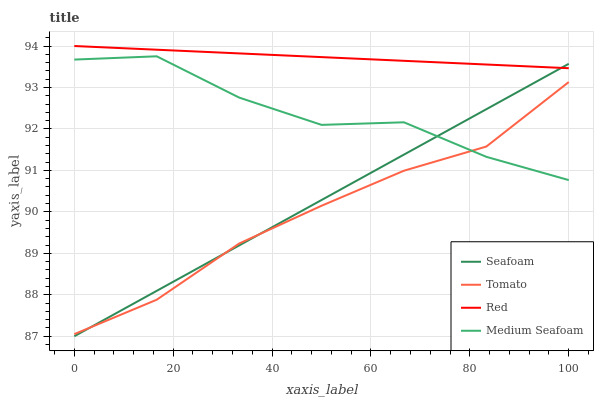Does Tomato have the minimum area under the curve?
Answer yes or no. Yes. Does Red have the maximum area under the curve?
Answer yes or no. Yes. Does Seafoam have the minimum area under the curve?
Answer yes or no. No. Does Seafoam have the maximum area under the curve?
Answer yes or no. No. Is Seafoam the smoothest?
Answer yes or no. Yes. Is Medium Seafoam the roughest?
Answer yes or no. Yes. Is Red the smoothest?
Answer yes or no. No. Is Red the roughest?
Answer yes or no. No. Does Red have the lowest value?
Answer yes or no. No. Does Red have the highest value?
Answer yes or no. Yes. Does Seafoam have the highest value?
Answer yes or no. No. Is Medium Seafoam less than Red?
Answer yes or no. Yes. Is Red greater than Tomato?
Answer yes or no. Yes. Does Medium Seafoam intersect Red?
Answer yes or no. No. 